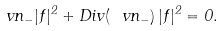Convert formula to latex. <formula><loc_0><loc_0><loc_500><loc_500>\ v n _ { - } | f | ^ { 2 } + D i v ( \ v n _ { - } ) \, | f | ^ { 2 } = 0 .</formula> 